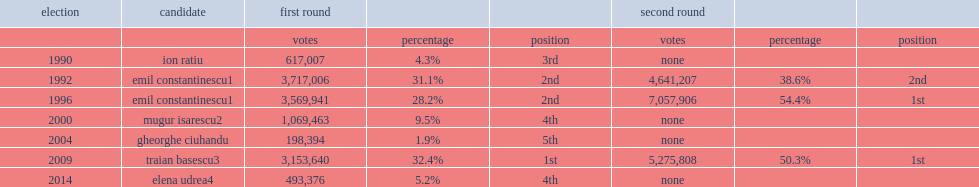What is the ranking for ciuhandu with 1.9% (or 198,394 votes)? 5th. 